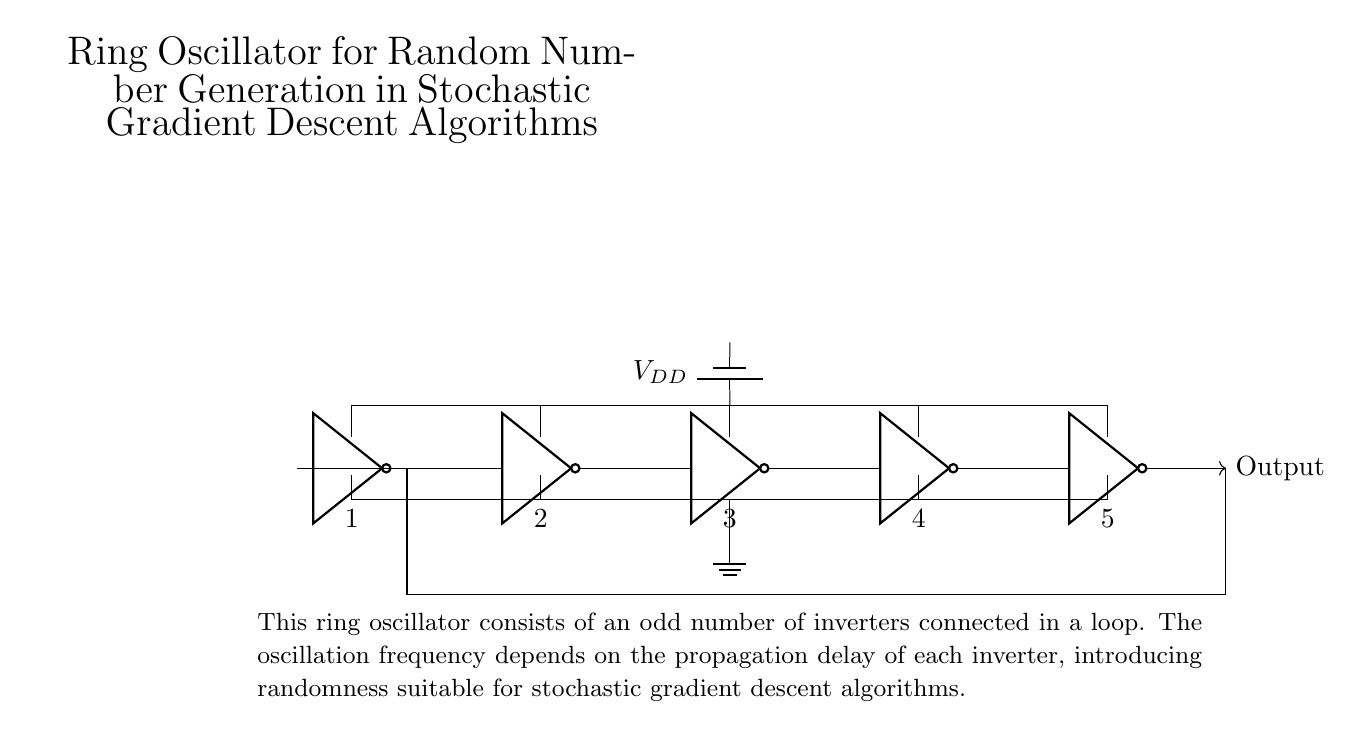What is the number of inverters in this ring oscillator? There are five inverters connected in a loop. This can be confirmed by counting the number of not ports in the circuit diagram.
Answer: 5 What is the function of the ring oscillator shown? The function of the ring oscillator is to generate an oscillating signal with a frequency determined by the propagation delay of each inverter. This is evident from the description in the diagram that mentions the relationship between delay and randomness.
Answer: Generate oscillating signal What type of voltage source is used in this circuit? A battery is used as the voltage source, as indicated by the battery symbol in the diagram, supplying power to the inverters.
Answer: Battery What is the effect of having an odd number of inverters in the ring oscillator? An odd number of inverters ensures that the circuit oscillates, producing a continuous output signal. If an even number of inverters were used, the system would not oscillate as it would reach a stable state.
Answer: Circuit oscillates What is the typical output frequency determined by in this oscillator? The output frequency is determined by the propagation delay through each inverter. This relationship is rooted in the timing of each inverter's output transitioning, which collectively influences the oscillation frequency.
Answer: Propagation delay How does this ring oscillator contribute to random number generation in stochastic gradient descent algorithms? The ring oscillator introduces randomness in its output frequency due to variations in the propagation delay circuits, which can be harnessed for generating random numbers useful in stochastic gradient descent algorithms. This is clearly outlined in the description of the circuit's application.
Answer: Introduces randomness What is the role of the ground in this circuit? The ground serves as a reference point for the voltage levels in the circuit, providing a common return path for electric current, and is essential for circuit stability. This is represented in the diagram with a ground node at the bottom.
Answer: Reference point 